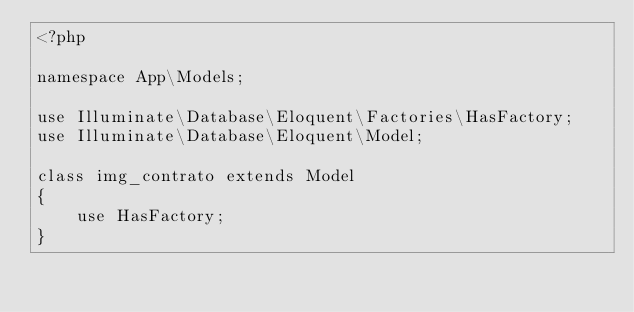<code> <loc_0><loc_0><loc_500><loc_500><_PHP_><?php

namespace App\Models;

use Illuminate\Database\Eloquent\Factories\HasFactory;
use Illuminate\Database\Eloquent\Model;

class img_contrato extends Model
{
    use HasFactory;
}
</code> 